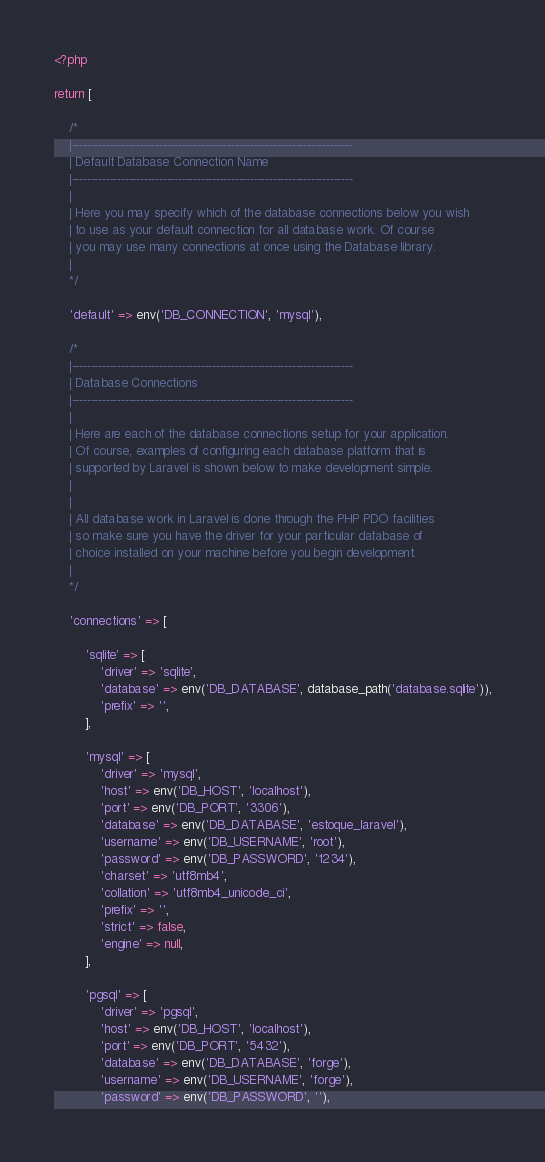<code> <loc_0><loc_0><loc_500><loc_500><_PHP_><?php

return [

    /*
    |--------------------------------------------------------------------------
    | Default Database Connection Name
    |--------------------------------------------------------------------------
    |
    | Here you may specify which of the database connections below you wish
    | to use as your default connection for all database work. Of course
    | you may use many connections at once using the Database library.
    |
    */

    'default' => env('DB_CONNECTION', 'mysql'),

    /*
    |--------------------------------------------------------------------------
    | Database Connections
    |--------------------------------------------------------------------------
    |
    | Here are each of the database connections setup for your application.
    | Of course, examples of configuring each database platform that is
    | supported by Laravel is shown below to make development simple.
    |
    |
    | All database work in Laravel is done through the PHP PDO facilities
    | so make sure you have the driver for your particular database of
    | choice installed on your machine before you begin development.
    |
    */

    'connections' => [

        'sqlite' => [
            'driver' => 'sqlite',
            'database' => env('DB_DATABASE', database_path('database.sqlite')),
            'prefix' => '',
        ],

        'mysql' => [
            'driver' => 'mysql',
            'host' => env('DB_HOST', 'localhost'),
            'port' => env('DB_PORT', '3306'),
            'database' => env('DB_DATABASE', 'estoque_laravel'),
            'username' => env('DB_USERNAME', 'root'),
            'password' => env('DB_PASSWORD', '1234'),
            'charset' => 'utf8mb4',
            'collation' => 'utf8mb4_unicode_ci',
            'prefix' => '',
            'strict' => false,
            'engine' => null,
        ],

        'pgsql' => [
            'driver' => 'pgsql',
            'host' => env('DB_HOST', 'localhost'),
            'port' => env('DB_PORT', '5432'),
            'database' => env('DB_DATABASE', 'forge'),
            'username' => env('DB_USERNAME', 'forge'),
            'password' => env('DB_PASSWORD', ''),</code> 